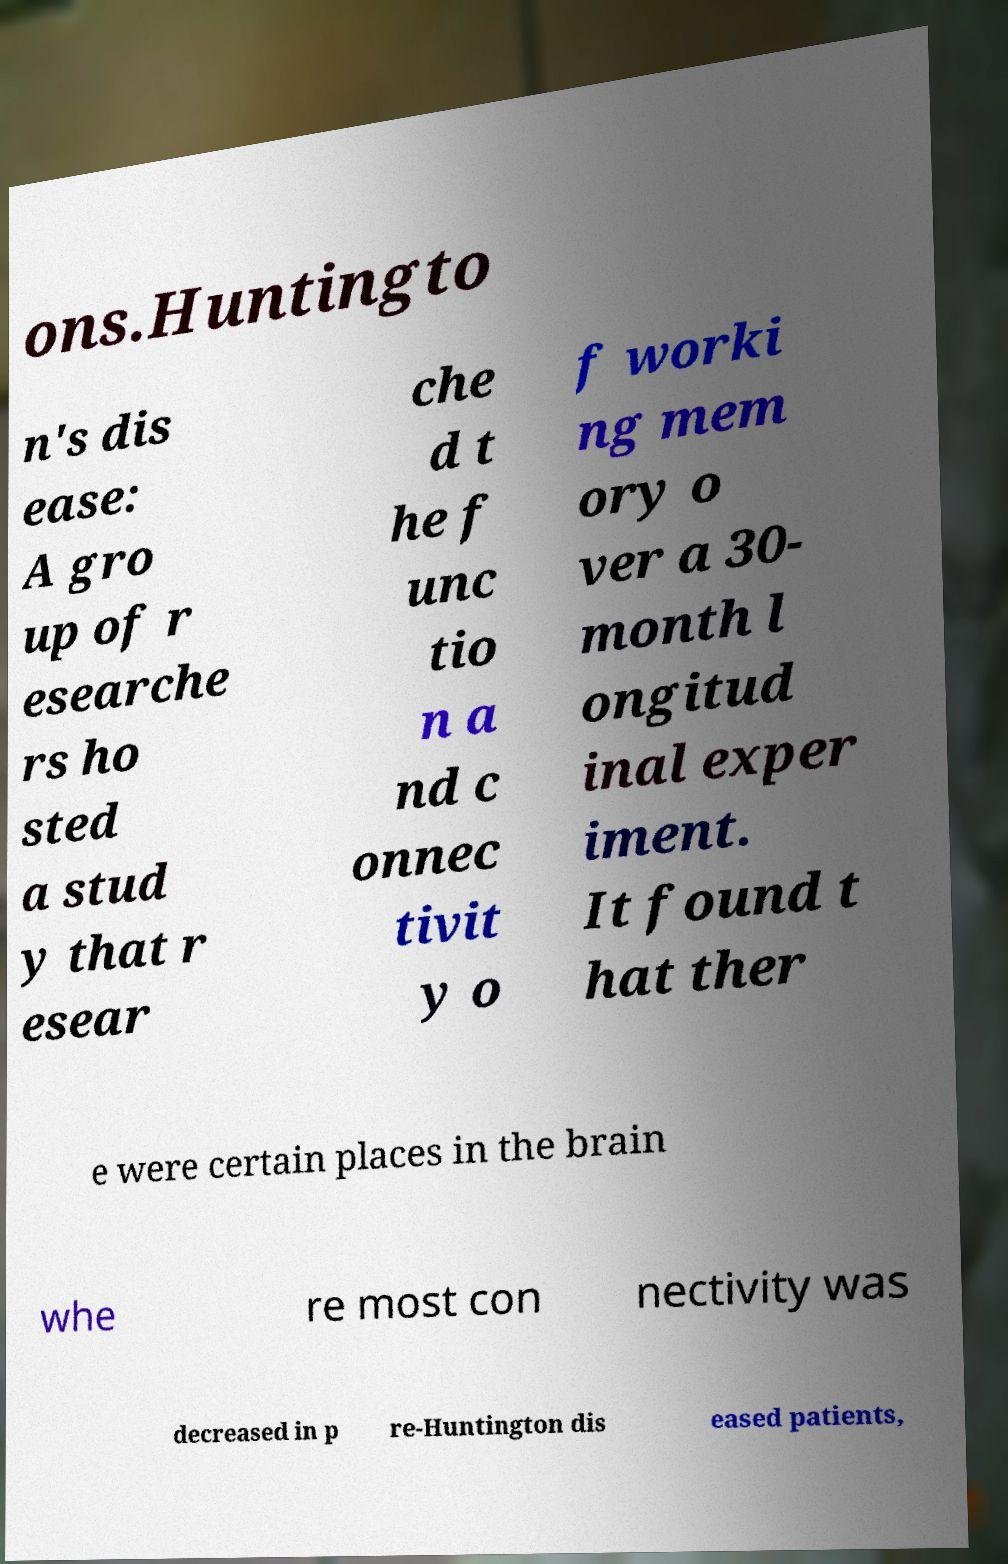What messages or text are displayed in this image? I need them in a readable, typed format. ons.Huntingto n's dis ease: A gro up of r esearche rs ho sted a stud y that r esear che d t he f unc tio n a nd c onnec tivit y o f worki ng mem ory o ver a 30- month l ongitud inal exper iment. It found t hat ther e were certain places in the brain whe re most con nectivity was decreased in p re-Huntington dis eased patients, 